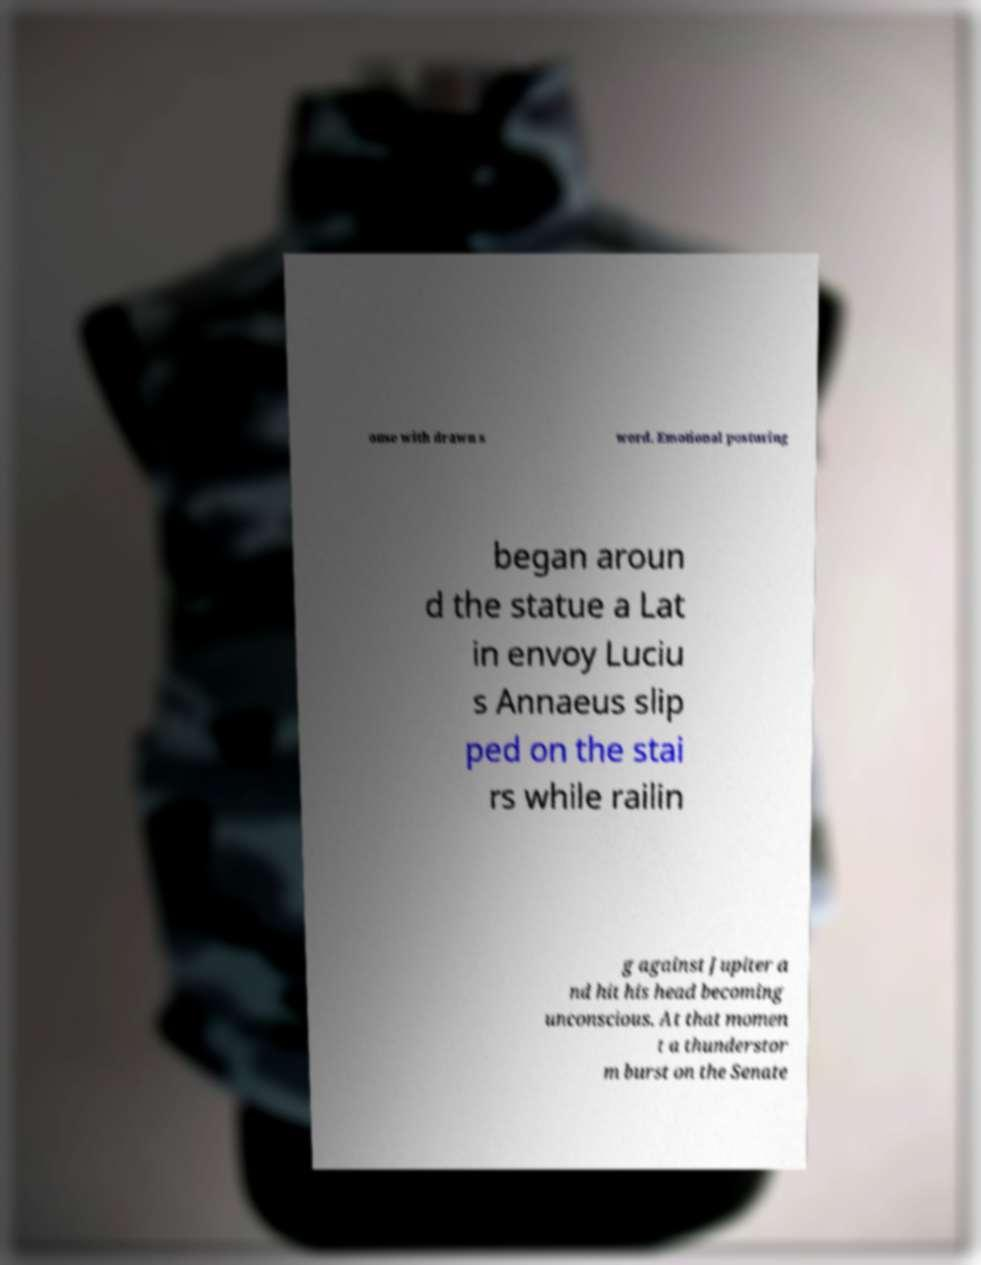Please identify and transcribe the text found in this image. ouse with drawn s word. Emotional posturing began aroun d the statue a Lat in envoy Luciu s Annaeus slip ped on the stai rs while railin g against Jupiter a nd hit his head becoming unconscious. At that momen t a thunderstor m burst on the Senate 